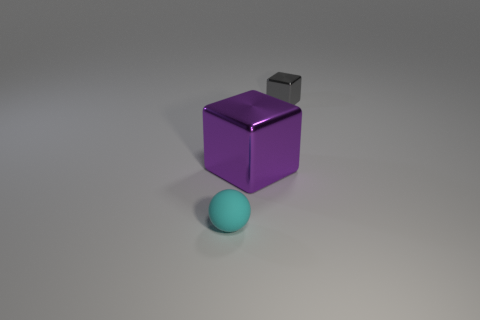Add 2 small blocks. How many objects exist? 5 Subtract all blocks. How many objects are left? 1 Subtract all big purple blocks. Subtract all large rubber cylinders. How many objects are left? 2 Add 2 small gray cubes. How many small gray cubes are left? 3 Add 2 brown metal things. How many brown metal things exist? 2 Subtract 0 brown cylinders. How many objects are left? 3 